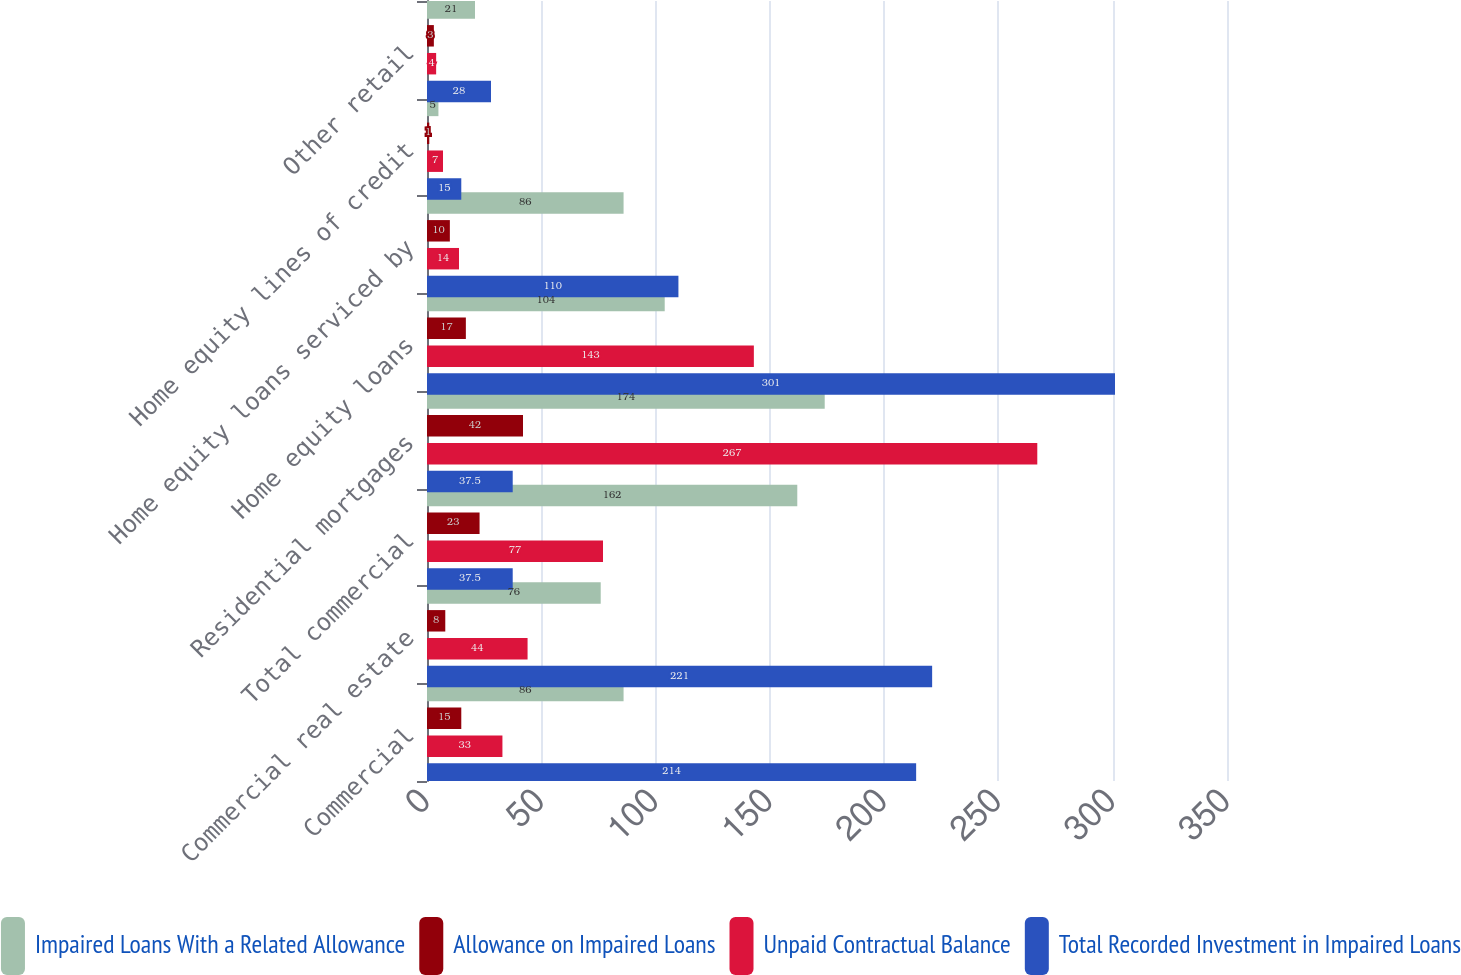Convert chart. <chart><loc_0><loc_0><loc_500><loc_500><stacked_bar_chart><ecel><fcel>Commercial<fcel>Commercial real estate<fcel>Total commercial<fcel>Residential mortgages<fcel>Home equity loans<fcel>Home equity loans serviced by<fcel>Home equity lines of credit<fcel>Other retail<nl><fcel>Impaired Loans With a Related Allowance<fcel>86<fcel>76<fcel>162<fcel>174<fcel>104<fcel>86<fcel>5<fcel>21<nl><fcel>Allowance on Impaired Loans<fcel>15<fcel>8<fcel>23<fcel>42<fcel>17<fcel>10<fcel>1<fcel>3<nl><fcel>Unpaid Contractual Balance<fcel>33<fcel>44<fcel>77<fcel>267<fcel>143<fcel>14<fcel>7<fcel>4<nl><fcel>Total Recorded Investment in Impaired Loans<fcel>214<fcel>221<fcel>37.5<fcel>37.5<fcel>301<fcel>110<fcel>15<fcel>28<nl></chart> 